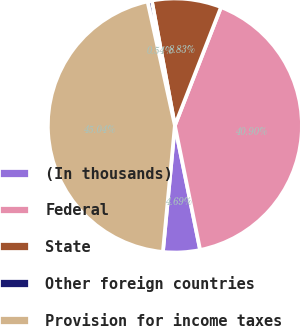<chart> <loc_0><loc_0><loc_500><loc_500><pie_chart><fcel>(In thousands)<fcel>Federal<fcel>State<fcel>Other foreign countries<fcel>Provision for income taxes<nl><fcel>4.69%<fcel>40.9%<fcel>8.83%<fcel>0.54%<fcel>45.04%<nl></chart> 